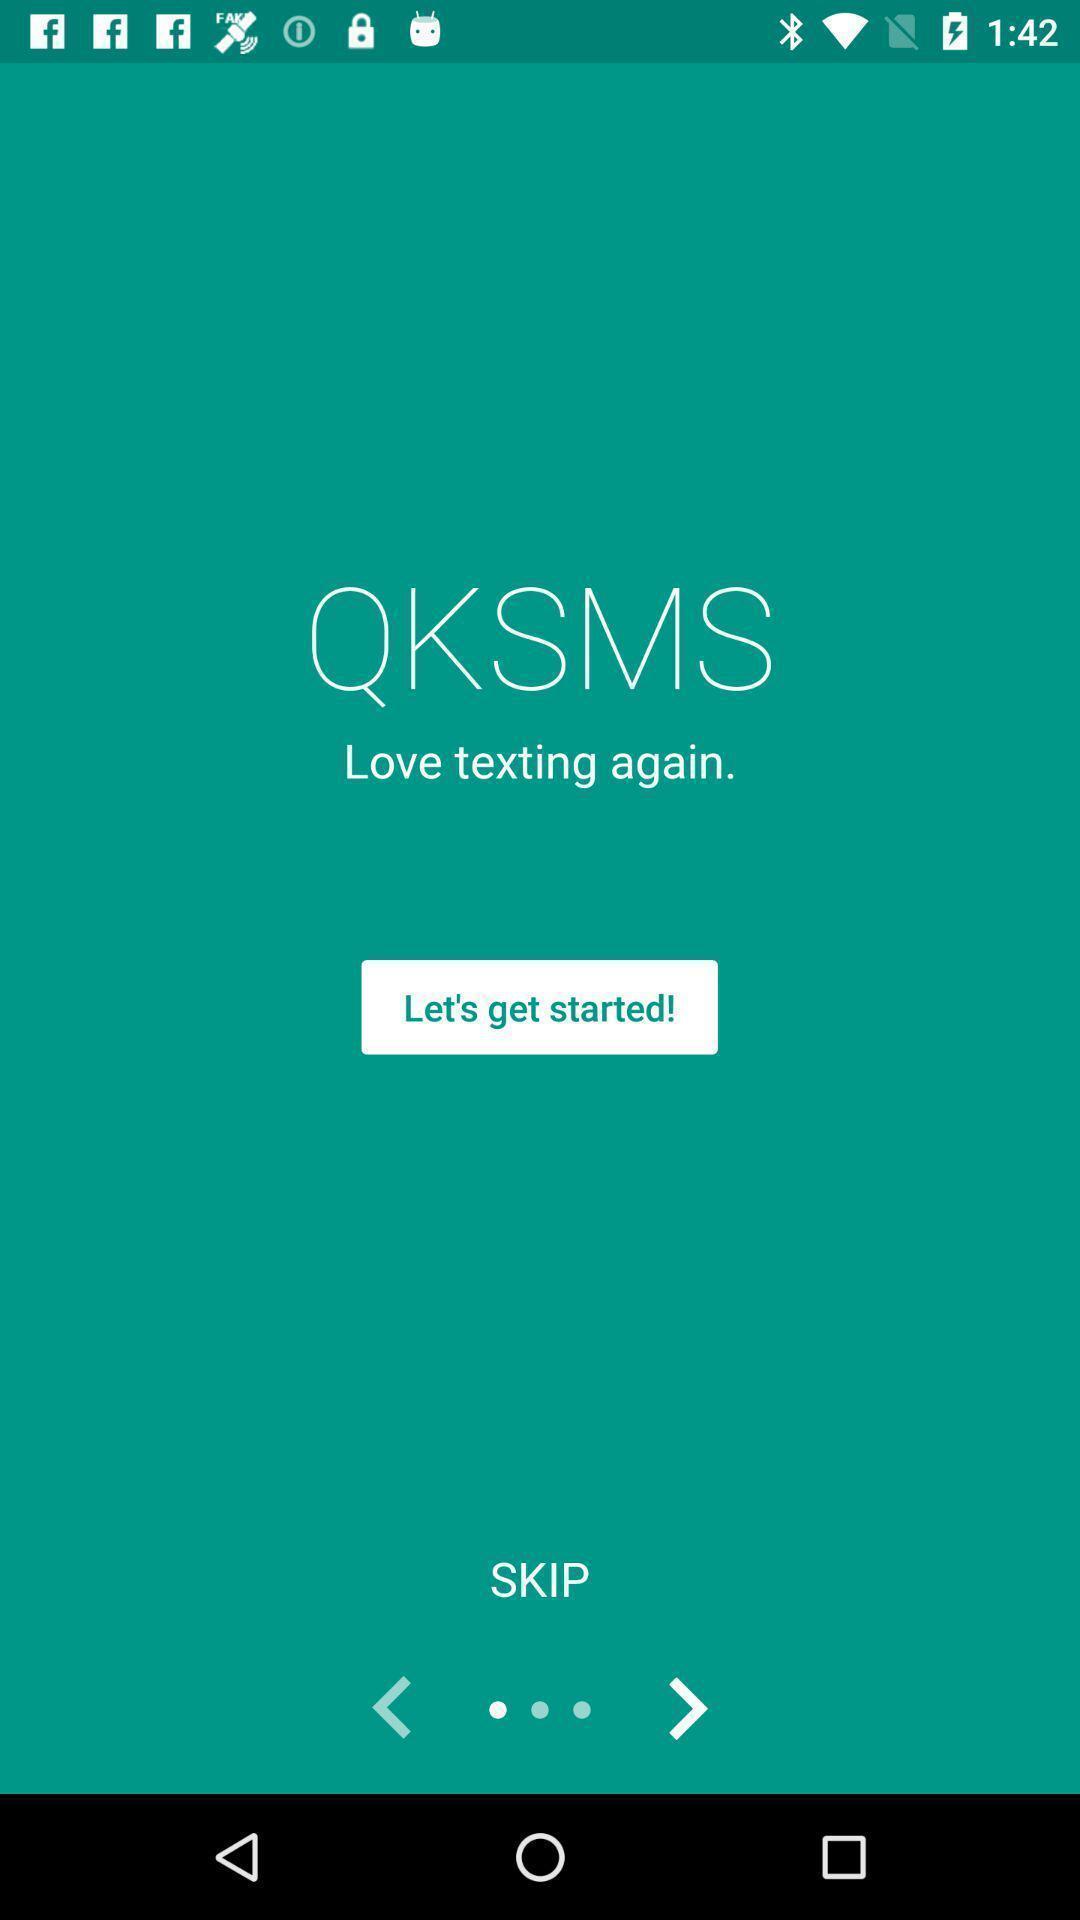Describe the visual elements of this screenshot. Welcome page of chatting application. 